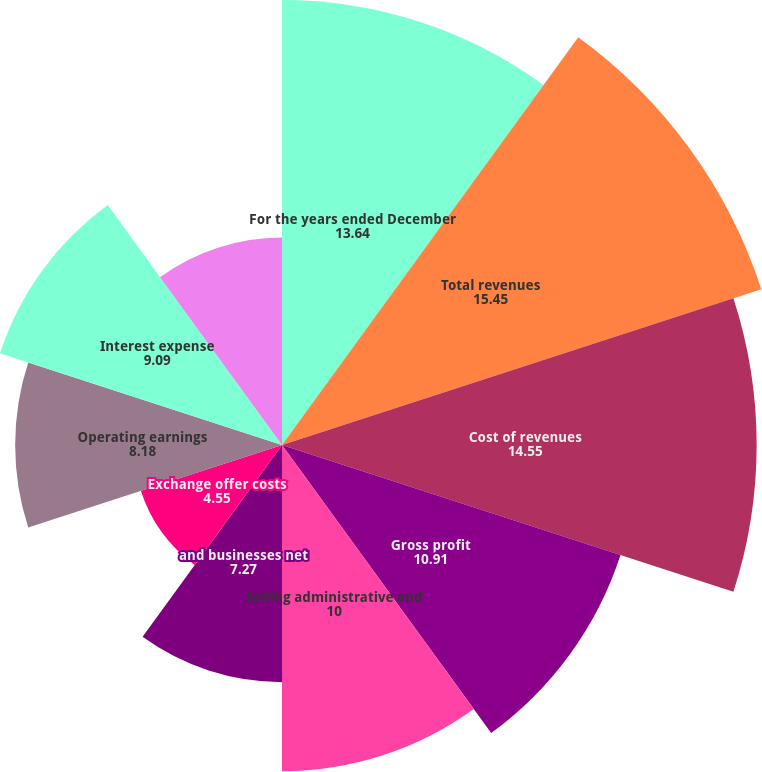Convert chart. <chart><loc_0><loc_0><loc_500><loc_500><pie_chart><fcel>For the years ended December<fcel>Total revenues<fcel>Cost of revenues<fcel>Gross profit<fcel>Selling administrative and<fcel>and businesses net<fcel>Exchange offer costs<fcel>Operating earnings<fcel>Interest expense<fcel>Earnings (loss) from<nl><fcel>13.64%<fcel>15.45%<fcel>14.55%<fcel>10.91%<fcel>10.0%<fcel>7.27%<fcel>4.55%<fcel>8.18%<fcel>9.09%<fcel>6.36%<nl></chart> 